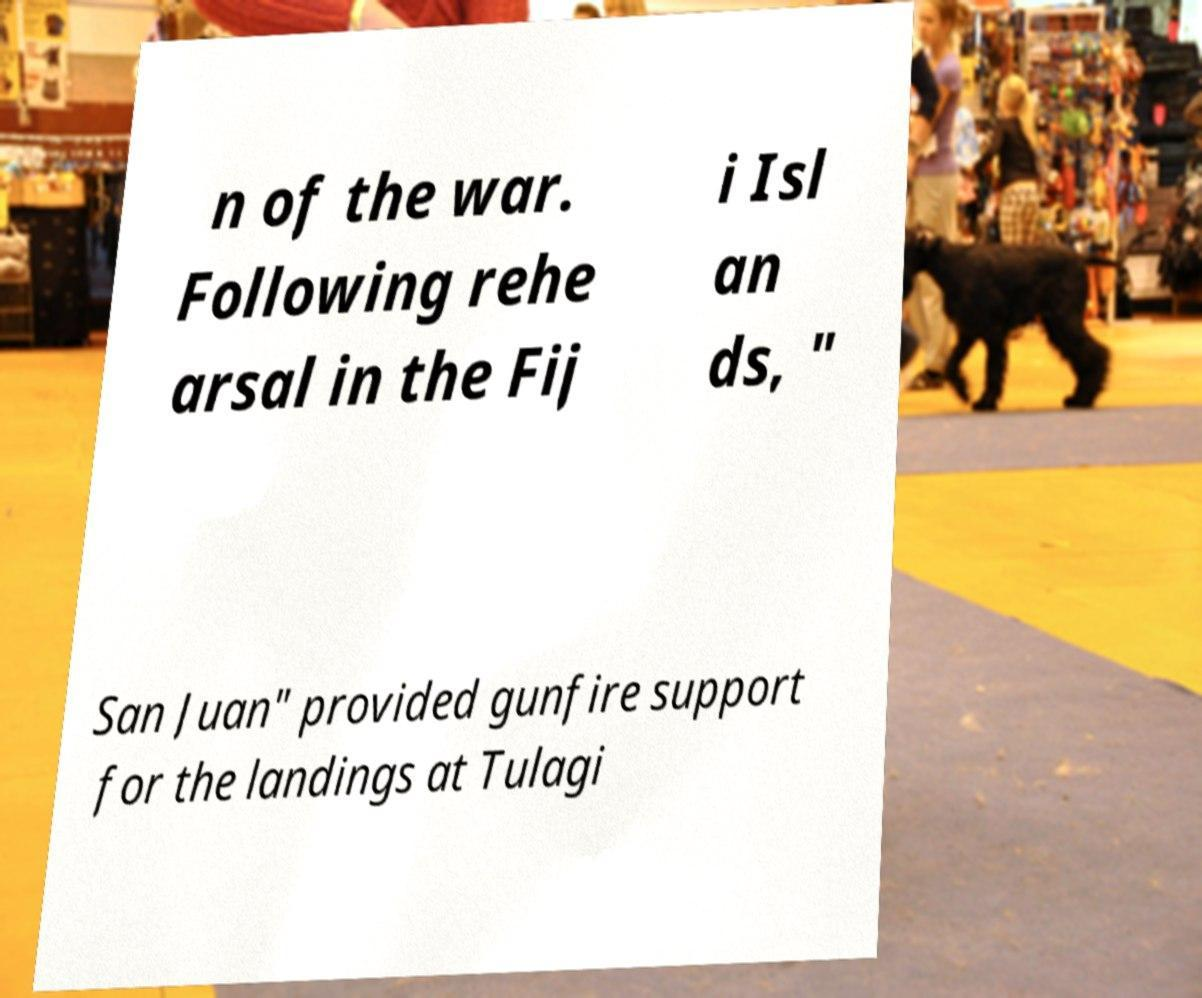Please read and relay the text visible in this image. What does it say? n of the war. Following rehe arsal in the Fij i Isl an ds, " San Juan" provided gunfire support for the landings at Tulagi 